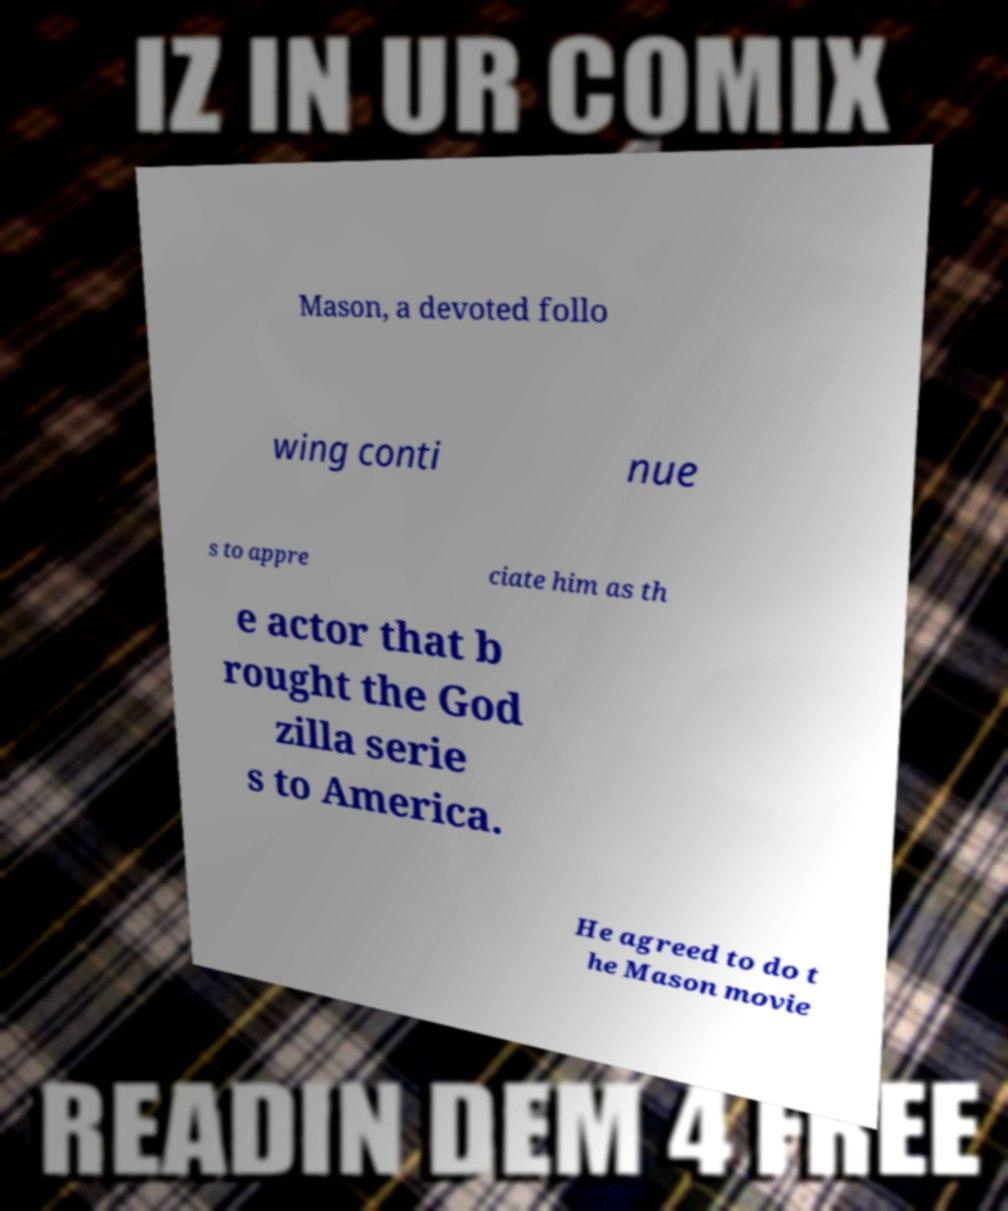Could you assist in decoding the text presented in this image and type it out clearly? Mason, a devoted follo wing conti nue s to appre ciate him as th e actor that b rought the God zilla serie s to America. He agreed to do t he Mason movie 